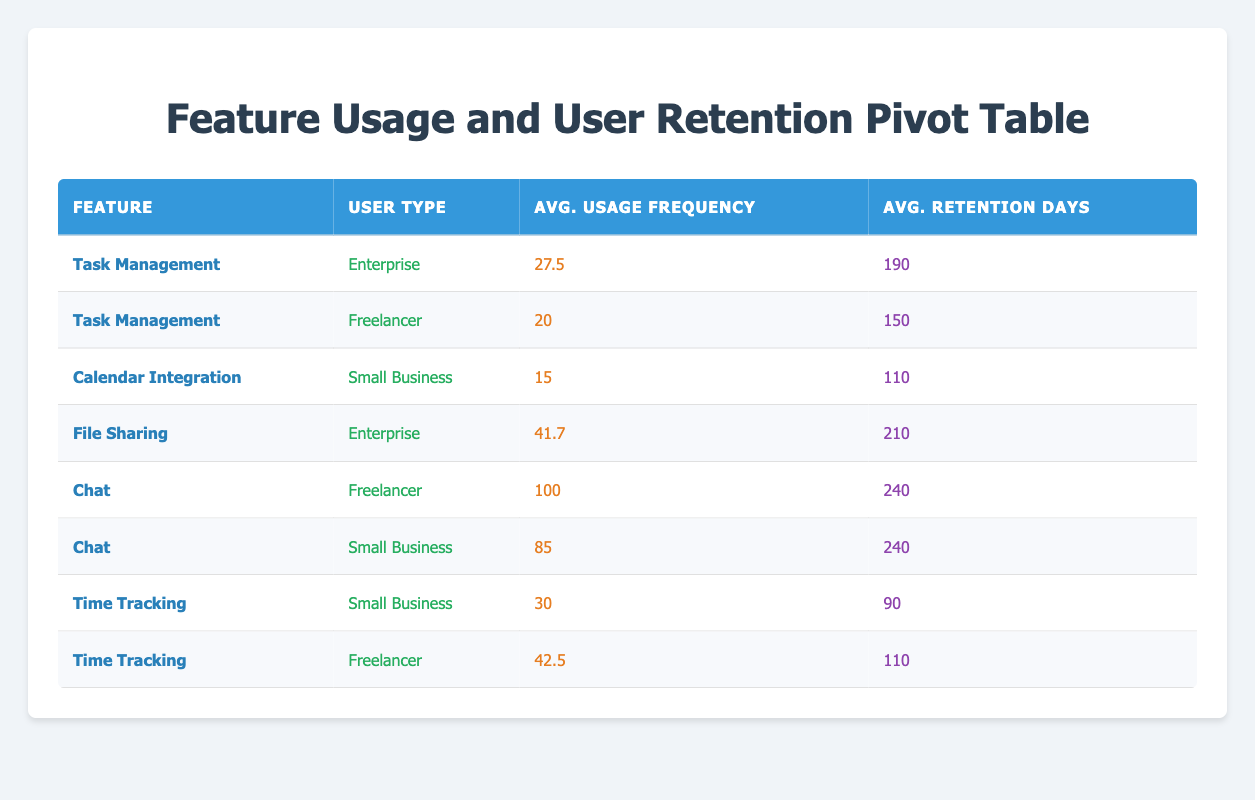What is the average usage frequency for the Task Management feature among Enterprise users? To find the average usage frequency for the Task Management feature among Enterprise users, we look at the usage frequency values listed for that feature under the Enterprise user type: 25 and 30. We sum these values: 25 + 30 = 55. Then we divide by the number of data points, which is 2. Therefore, the average is 55 / 2 = 27.5.
Answer: 27.5 Which feature has the highest average retention days among Small Business users? Looking at the Small Business user type, we identify the average retention days for each feature: Calendar Integration has 110, Chat has 240, and Time Tracking has 90. The maximum value among these is for the Chat feature, which is 240.
Answer: Chat Is the average usage frequency for File Sharing greater than 40? The average usage frequency for File Sharing is calculated from the two entries listed for that feature: 40 and 35. It sums to 75. To find the average, we divide 75 by the number of entries (2): 75 / 2 = 37.5, which is less than 40.
Answer: No Does the Chat feature show the same average retention days for both user types reported? The average retention days for Chat feature under different user types are: for Freelancer it is 240 and for Small Business it is also 240. Since both values are identical, they confirm that the Chat feature shows the same retention days across both groups.
Answer: Yes What is the total average usage frequency across all features for Freelancer users? We first extract the usage frequency values for Freelancer users, which are 20 (Task Management), 100 (Chat), and 42.5 (Time Tracking). We sum these frequencies: 20 + 100 + 42.5 = 162. We then divide by the number of entries (3) to find the average: 162 / 3 = 54.
Answer: 54 Among all user types, which feature has the highest average retention days? We need to calculate the average retention days for each feature. The retention days values are: Task Management (190, 150), Calendar Integration (110), File Sharing (210, 240), Chat (240, 240), and Time Tracking (90, 110). The averages are calculated as follows: Task Management -> (190 + 150) / 2 = 170, Calendar Integration -> 110, File Sharing -> (210 + 240) / 2 = 225, Chat -> (240 + 240) / 2 = 240, Time Tracking -> (90 + 110) / 2 = 100. The highest average is for Chat at 240.
Answer: Chat What is the difference between the average usage frequency of Time Tracking and Calendar Integration for Small Business users? For Small Business users, the average usage frequency for Time Tracking is 30 and for Calendar Integration it is 15. Calculating the difference: 30 - 15 = 15. Therefore, Time Tracking has a higher usage frequency by 15.
Answer: 15 Is the retention days for the Time Tracking feature lower than 100 for any user type? The retention days for Time Tracking are 90 for Small Business users, which is below 100. The other entry for Time Tracking (Freelancer) has 110, which is above 100. Thus, there is at least one instance where retention days are lower than 100.
Answer: Yes 